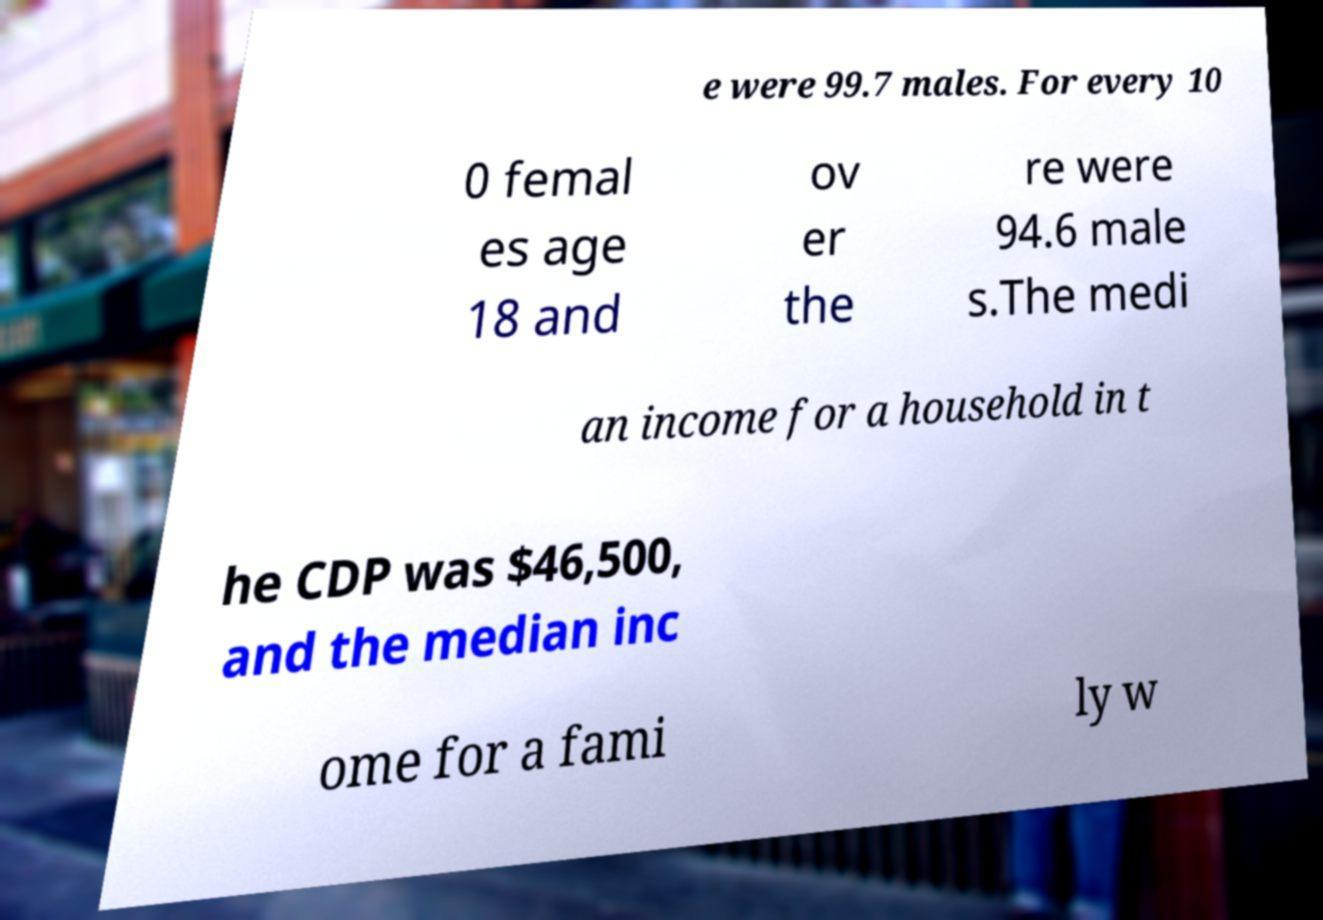I need the written content from this picture converted into text. Can you do that? e were 99.7 males. For every 10 0 femal es age 18 and ov er the re were 94.6 male s.The medi an income for a household in t he CDP was $46,500, and the median inc ome for a fami ly w 